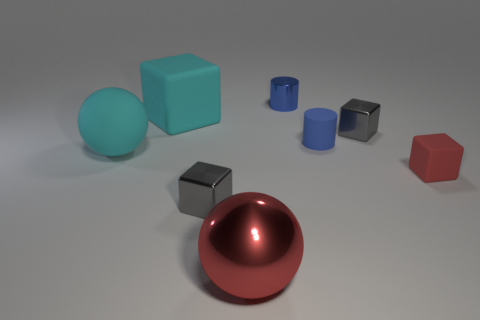Subtract all purple cylinders. How many gray blocks are left? 2 Subtract all tiny red cubes. How many cubes are left? 3 Add 1 gray metal balls. How many objects exist? 9 Subtract all red blocks. How many blocks are left? 3 Subtract all cylinders. How many objects are left? 6 Add 6 matte things. How many matte things are left? 10 Add 4 large metal objects. How many large metal objects exist? 5 Subtract 0 purple cylinders. How many objects are left? 8 Subtract all red cylinders. Subtract all brown cubes. How many cylinders are left? 2 Subtract all purple metallic cylinders. Subtract all red metal things. How many objects are left? 7 